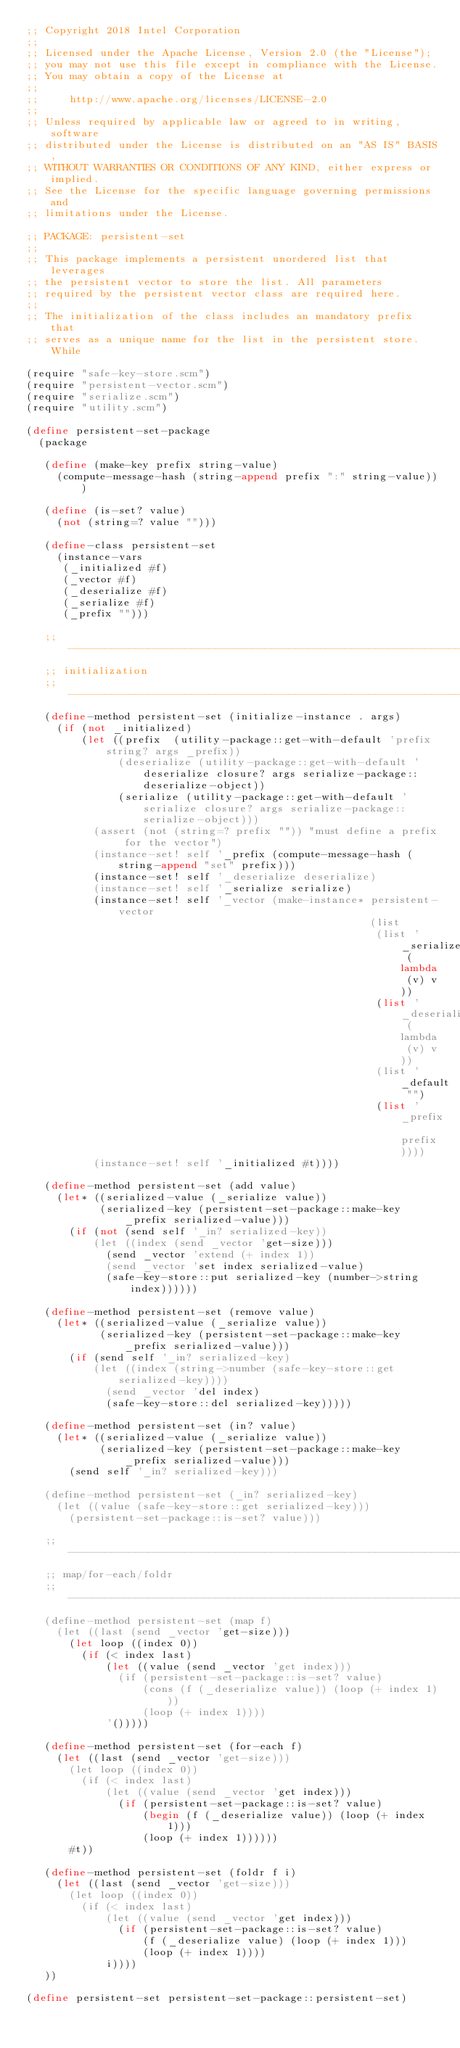Convert code to text. <code><loc_0><loc_0><loc_500><loc_500><_Scheme_>;; Copyright 2018 Intel Corporation
;;
;; Licensed under the Apache License, Version 2.0 (the "License");
;; you may not use this file except in compliance with the License.
;; You may obtain a copy of the License at
;;
;;     http://www.apache.org/licenses/LICENSE-2.0
;;
;; Unless required by applicable law or agreed to in writing, software
;; distributed under the License is distributed on an "AS IS" BASIS,
;; WITHOUT WARRANTIES OR CONDITIONS OF ANY KIND, either express or implied.
;; See the License for the specific language governing permissions and
;; limitations under the License.

;; PACKAGE: persistent-set
;;
;; This package implements a persistent unordered list that leverages
;; the persistent vector to store the list. All parameters
;; required by the persistent vector class are required here.
;;
;; The initialization of the class includes an mandatory prefix that
;; serves as a unique name for the list in the persistent store. While

(require "safe-key-store.scm")
(require "persistent-vector.scm")
(require "serialize.scm")
(require "utility.scm")

(define persistent-set-package
  (package

   (define (make-key prefix string-value)
     (compute-message-hash (string-append prefix ":" string-value)))

   (define (is-set? value)
     (not (string=? value "")))

   (define-class persistent-set
     (instance-vars
      (_initialized #f)
      (_vector #f)
      (_deserialize #f)
      (_serialize #f)
      (_prefix "")))

   ;; -----------------------------------------------------------------
   ;; initialization
   ;; -----------------------------------------------------------------
   (define-method persistent-set (initialize-instance . args)
     (if (not _initialized)
         (let ((prefix  (utility-package::get-with-default 'prefix string? args _prefix))
               (deserialize (utility-package::get-with-default 'deserialize closure? args serialize-package::deserialize-object))
               (serialize (utility-package::get-with-default 'serialize closure? args serialize-package::serialize-object)))
           (assert (not (string=? prefix "")) "must define a prefix for the vector")
           (instance-set! self '_prefix (compute-message-hash (string-append "set" prefix)))
           (instance-set! self '_deserialize deserialize)
           (instance-set! self '_serialize serialize)
           (instance-set! self '_vector (make-instance* persistent-vector
                                                        (list
                                                         (list '_serialize (lambda (v) v))
                                                         (list '_deserialize (lambda (v) v))
                                                         (list '_default "")
                                                         (list '_prefix prefix))))
           (instance-set! self '_initialized #t))))

   (define-method persistent-set (add value)
     (let* ((serialized-value (_serialize value))
            (serialized-key (persistent-set-package::make-key _prefix serialized-value)))
       (if (not (send self '_in? serialized-key))
           (let ((index (send _vector 'get-size)))
             (send _vector 'extend (+ index 1))
             (send _vector 'set index serialized-value)
             (safe-key-store::put serialized-key (number->string index))))))

   (define-method persistent-set (remove value)
     (let* ((serialized-value (_serialize value))
            (serialized-key (persistent-set-package::make-key _prefix serialized-value)))
       (if (send self '_in? serialized-key)
           (let ((index (string->number (safe-key-store::get serialized-key))))
             (send _vector 'del index)
             (safe-key-store::del serialized-key)))))

   (define-method persistent-set (in? value)
     (let* ((serialized-value (_serialize value))
            (serialized-key (persistent-set-package::make-key _prefix serialized-value)))
       (send self '_in? serialized-key)))

   (define-method persistent-set (_in? serialized-key)
     (let ((value (safe-key-store::get serialized-key)))
       (persistent-set-package::is-set? value)))

   ;; -----------------------------------------------------------------
   ;; map/for-each/foldr
   ;; -----------------------------------------------------------------
   (define-method persistent-set (map f)
     (let ((last (send _vector 'get-size)))
       (let loop ((index 0))
         (if (< index last)
             (let ((value (send _vector 'get index)))
               (if (persistent-set-package::is-set? value)
                   (cons (f (_deserialize value)) (loop (+ index 1)))
                   (loop (+ index 1))))
             '()))))

   (define-method persistent-set (for-each f)
     (let ((last (send _vector 'get-size)))
       (let loop ((index 0))
         (if (< index last)
             (let ((value (send _vector 'get index)))
               (if (persistent-set-package::is-set? value)
                   (begin (f (_deserialize value)) (loop (+ index 1)))
                   (loop (+ index 1))))))
       #t))

   (define-method persistent-set (foldr f i)
     (let ((last (send _vector 'get-size)))
       (let loop ((index 0))
         (if (< index last)
             (let ((value (send _vector 'get index)))
               (if (persistent-set-package::is-set? value)
                   (f (_deserialize value) (loop (+ index 1)))
                   (loop (+ index 1))))
             i))))
   ))

(define persistent-set persistent-set-package::persistent-set)
</code> 